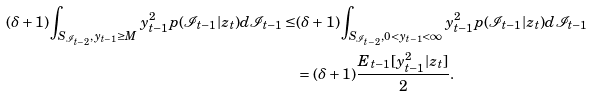Convert formula to latex. <formula><loc_0><loc_0><loc_500><loc_500>( \delta + 1 ) \int _ { S _ { \mathcal { I } _ { t - 2 } } , y _ { t - 1 } \geq M } { y ^ { 2 } _ { t - 1 } p ( \mathcal { I } _ { t - 1 } | z _ { t } ) d \mathcal { I } _ { t - 1 } } \leq & ( \delta + 1 ) \int _ { S _ { \mathcal { I } _ { t - 2 } } , 0 < y _ { t - 1 } < \infty } { y ^ { 2 } _ { t - 1 } p ( \mathcal { I } _ { t - 1 } | z _ { t } ) d \mathcal { I } _ { t - 1 } } \\ & = ( \delta + 1 ) \frac { E _ { t - 1 } [ y ^ { 2 } _ { t - 1 } | z _ { t } ] } { 2 } .</formula> 